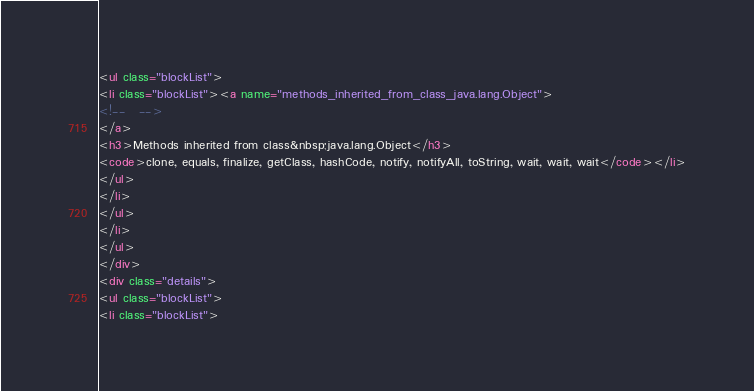Convert code to text. <code><loc_0><loc_0><loc_500><loc_500><_HTML_><ul class="blockList">
<li class="blockList"><a name="methods_inherited_from_class_java.lang.Object">
<!--   -->
</a>
<h3>Methods inherited from class&nbsp;java.lang.Object</h3>
<code>clone, equals, finalize, getClass, hashCode, notify, notifyAll, toString, wait, wait, wait</code></li>
</ul>
</li>
</ul>
</li>
</ul>
</div>
<div class="details">
<ul class="blockList">
<li class="blockList"></code> 